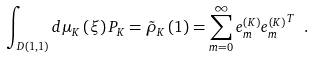<formula> <loc_0><loc_0><loc_500><loc_500>\int _ { D ( 1 , 1 ) } { d \mu _ { K } \left ( \xi \right ) P _ { K } = { \tilde { \rho } } _ { K } \left ( 1 \right ) = \sum _ { m = 0 } ^ { \infty } { { e } _ { m } ^ { \left ( K \right ) } { { e } _ { m } ^ { \left ( K \right ) } } ^ { T } } } \ .</formula> 